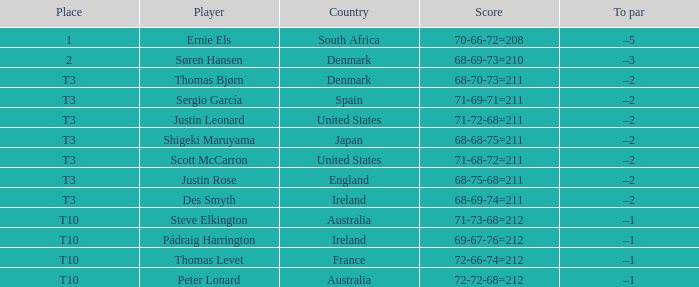What player scored 71-69-71=211? Sergio García. 